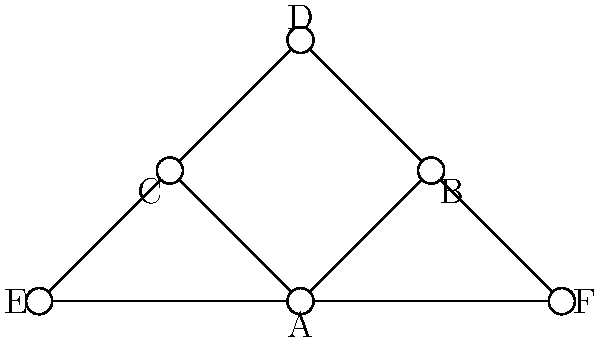In a mental health referral network, therapists are represented as nodes, and referrals between them are represented as edges. Given the graph above, which therapist has the highest degree centrality, and how might this impact the referral network's efficiency? To answer this question, we need to follow these steps:

1. Understand degree centrality:
   Degree centrality is a measure of the number of direct connections a node has in a network.

2. Count the connections for each therapist:
   A: 5 connections (B, C, D, E, F)
   B: 3 connections (A, D, F)
   C: 3 connections (A, D, E)
   D: 3 connections (A, B, C)
   E: 2 connections (A, C)
   F: 2 connections (A, B)

3. Identify the highest degree centrality:
   Therapist A has the highest degree centrality with 5 connections.

4. Consider the impact on network efficiency:
   - Therapist A acts as a hub in the network, facilitating more referrals.
   - This central position can lead to faster information flow and resource distribution.
   - However, it may also create a bottleneck if Therapist A becomes overwhelmed.
   - The network might benefit from developing more distributed connections to improve resilience.

5. Relate to evidence-based practices:
   - High centrality can be beneficial for implementing and disseminating evidence-based practices.
   - Therapist A could be instrumental in training and supporting others in the network.
   - However, over-reliance on one central figure may limit diverse perspectives and approaches.
Answer: Therapist A has the highest degree centrality (5 connections), potentially improving information flow but risking network bottleneck. 